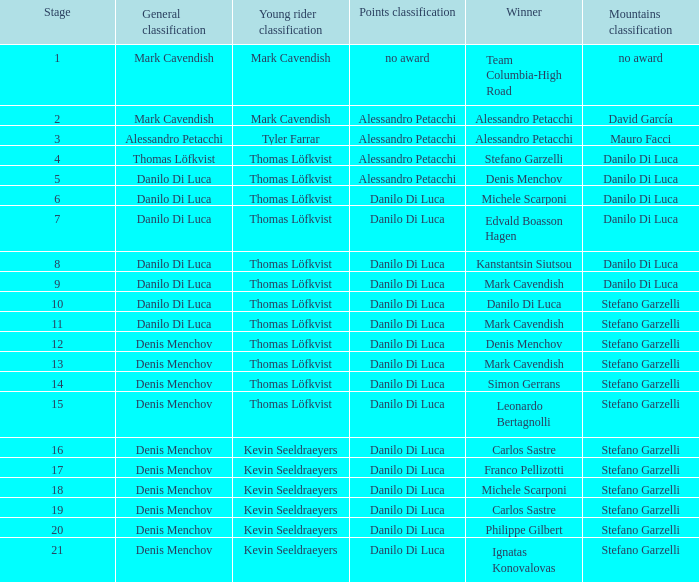When danilo di luca is the winner who is the general classification?  Danilo Di Luca. Write the full table. {'header': ['Stage', 'General classification', 'Young rider classification', 'Points classification', 'Winner', 'Mountains classification'], 'rows': [['1', 'Mark Cavendish', 'Mark Cavendish', 'no award', 'Team Columbia-High Road', 'no award'], ['2', 'Mark Cavendish', 'Mark Cavendish', 'Alessandro Petacchi', 'Alessandro Petacchi', 'David García'], ['3', 'Alessandro Petacchi', 'Tyler Farrar', 'Alessandro Petacchi', 'Alessandro Petacchi', 'Mauro Facci'], ['4', 'Thomas Löfkvist', 'Thomas Löfkvist', 'Alessandro Petacchi', 'Stefano Garzelli', 'Danilo Di Luca'], ['5', 'Danilo Di Luca', 'Thomas Löfkvist', 'Alessandro Petacchi', 'Denis Menchov', 'Danilo Di Luca'], ['6', 'Danilo Di Luca', 'Thomas Löfkvist', 'Danilo Di Luca', 'Michele Scarponi', 'Danilo Di Luca'], ['7', 'Danilo Di Luca', 'Thomas Löfkvist', 'Danilo Di Luca', 'Edvald Boasson Hagen', 'Danilo Di Luca'], ['8', 'Danilo Di Luca', 'Thomas Löfkvist', 'Danilo Di Luca', 'Kanstantsin Siutsou', 'Danilo Di Luca'], ['9', 'Danilo Di Luca', 'Thomas Löfkvist', 'Danilo Di Luca', 'Mark Cavendish', 'Danilo Di Luca'], ['10', 'Danilo Di Luca', 'Thomas Löfkvist', 'Danilo Di Luca', 'Danilo Di Luca', 'Stefano Garzelli'], ['11', 'Danilo Di Luca', 'Thomas Löfkvist', 'Danilo Di Luca', 'Mark Cavendish', 'Stefano Garzelli'], ['12', 'Denis Menchov', 'Thomas Löfkvist', 'Danilo Di Luca', 'Denis Menchov', 'Stefano Garzelli'], ['13', 'Denis Menchov', 'Thomas Löfkvist', 'Danilo Di Luca', 'Mark Cavendish', 'Stefano Garzelli'], ['14', 'Denis Menchov', 'Thomas Löfkvist', 'Danilo Di Luca', 'Simon Gerrans', 'Stefano Garzelli'], ['15', 'Denis Menchov', 'Thomas Löfkvist', 'Danilo Di Luca', 'Leonardo Bertagnolli', 'Stefano Garzelli'], ['16', 'Denis Menchov', 'Kevin Seeldraeyers', 'Danilo Di Luca', 'Carlos Sastre', 'Stefano Garzelli'], ['17', 'Denis Menchov', 'Kevin Seeldraeyers', 'Danilo Di Luca', 'Franco Pellizotti', 'Stefano Garzelli'], ['18', 'Denis Menchov', 'Kevin Seeldraeyers', 'Danilo Di Luca', 'Michele Scarponi', 'Stefano Garzelli'], ['19', 'Denis Menchov', 'Kevin Seeldraeyers', 'Danilo Di Luca', 'Carlos Sastre', 'Stefano Garzelli'], ['20', 'Denis Menchov', 'Kevin Seeldraeyers', 'Danilo Di Luca', 'Philippe Gilbert', 'Stefano Garzelli'], ['21', 'Denis Menchov', 'Kevin Seeldraeyers', 'Danilo Di Luca', 'Ignatas Konovalovas', 'Stefano Garzelli']]} 